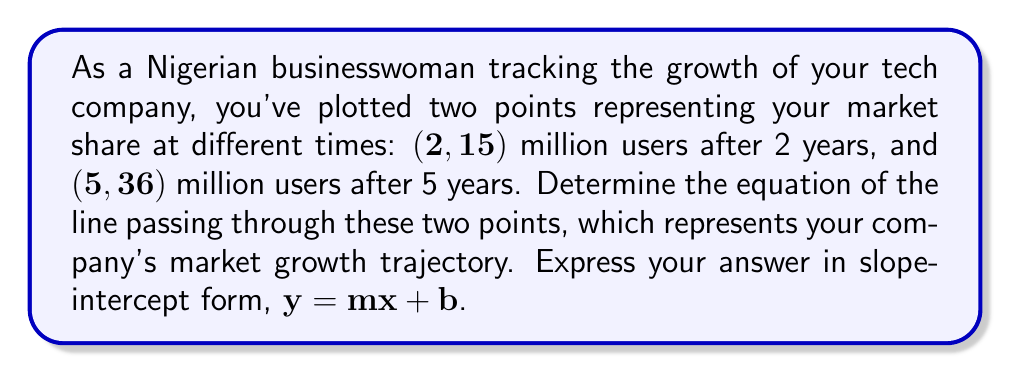Help me with this question. Let's approach this step-by-step:

1) We have two points: $(x_1, y_1) = (2, 15)$ and $(x_2, y_2) = (5, 36)$

2) To find the equation of the line, we first need to calculate the slope (m):

   $$m = \frac{y_2 - y_1}{x_2 - x_1} = \frac{36 - 15}{5 - 2} = \frac{21}{3} = 7$$

3) Now that we have the slope, we can use the point-slope form of a line:
   
   $$y - y_1 = m(x - x_1)$$

4) Let's use the point $(2, 15)$:

   $$y - 15 = 7(x - 2)$$

5) Expand the right side:

   $$y - 15 = 7x - 14$$

6) Add 15 to both sides to isolate y:

   $$y = 7x - 14 + 15$$

7) Simplify:

   $$y = 7x + 1$$

This is now in slope-intercept form, where $m = 7$ and $b = 1$.
Answer: $y = 7x + 1$ 